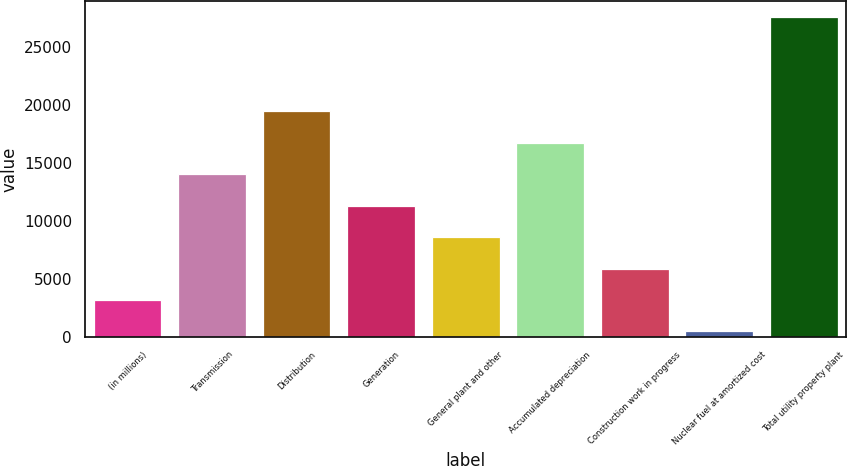<chart> <loc_0><loc_0><loc_500><loc_500><bar_chart><fcel>(in millions)<fcel>Transmission<fcel>Distribution<fcel>Generation<fcel>General plant and other<fcel>Accumulated depreciation<fcel>Construction work in progress<fcel>Nuclear fuel at amortized cost<fcel>Total utility property plant<nl><fcel>3188.9<fcel>14024.5<fcel>19442.3<fcel>11315.6<fcel>8606.7<fcel>16733.4<fcel>5897.8<fcel>480<fcel>27569<nl></chart> 